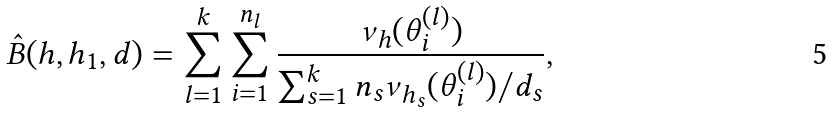<formula> <loc_0><loc_0><loc_500><loc_500>\hat { B } ( h , h _ { 1 } , d ) = \sum _ { l = 1 } ^ { k } \sum _ { i = 1 } ^ { n _ { l } } \frac { \nu _ { h } ( \theta _ { i } ^ { ( l ) } ) } { \sum _ { s = 1 } ^ { k } n _ { s } \nu _ { h _ { s } } ( \theta _ { i } ^ { ( l ) } ) / d _ { s } } ,</formula> 